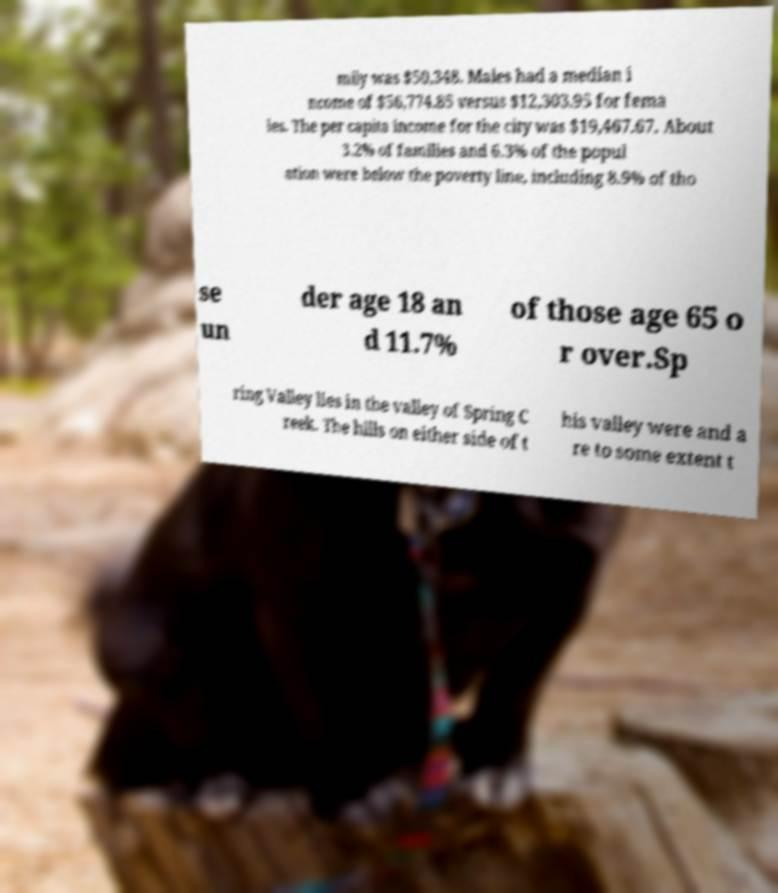For documentation purposes, I need the text within this image transcribed. Could you provide that? mily was $50,348. Males had a median i ncome of $56,774.85 versus $12,303.95 for fema les. The per capita income for the city was $19,467.67. About 3.2% of families and 6.3% of the popul ation were below the poverty line, including 8.9% of tho se un der age 18 an d 11.7% of those age 65 o r over.Sp ring Valley lies in the valley of Spring C reek. The hills on either side of t his valley were and a re to some extent t 